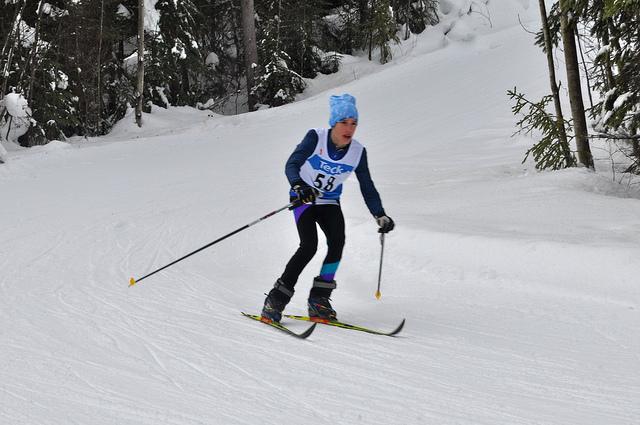Which sport is this?
Be succinct. Skiing. Is this an awkward stance?
Write a very short answer. No. Is the man wearing glasses?
Answer briefly. No. What is he holding in his hands?
Give a very brief answer. Ski poles. What does his vest say?
Keep it brief. 58. Are both ski's touching the ground?
Give a very brief answer. Yes. What is the person wearing on top of their head?
Write a very short answer. Hat. 